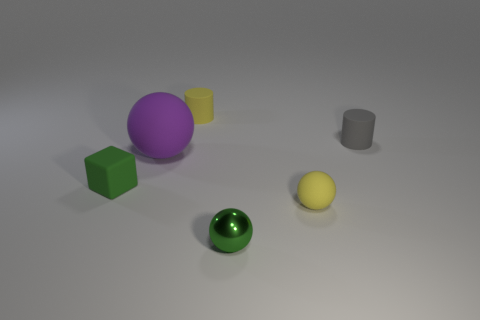What textures are present among the objects? The objects in the image show varying textures: the green sphere and the metal object have a shiny, reflective surface, while the purple sphere has a matte finish. The yellow cylinder, the grey cylinder, and the green cube appear to have a slightly textured, less reflective surface, which could be indicative of a different material such as plastic or painted wood. 